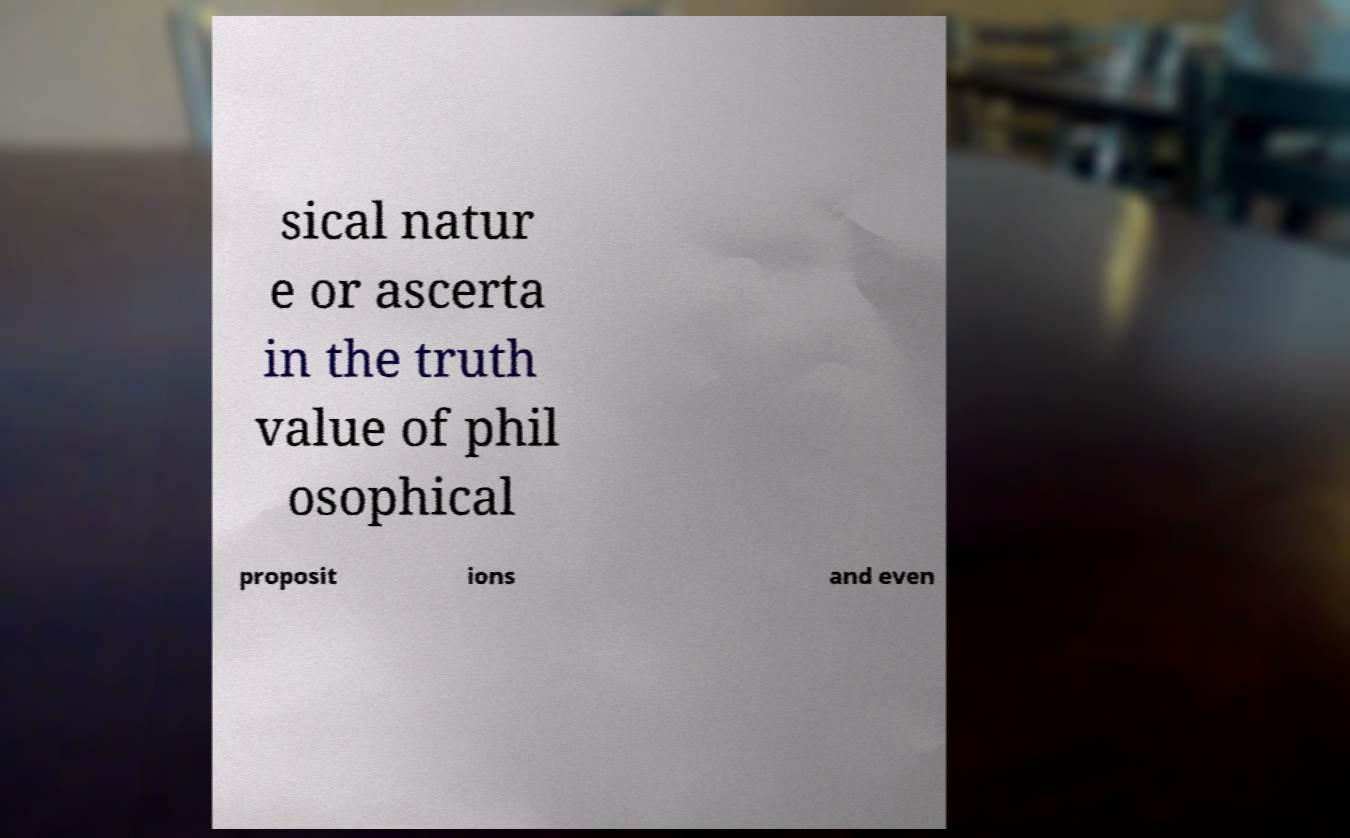Please identify and transcribe the text found in this image. sical natur e or ascerta in the truth value of phil osophical proposit ions and even 